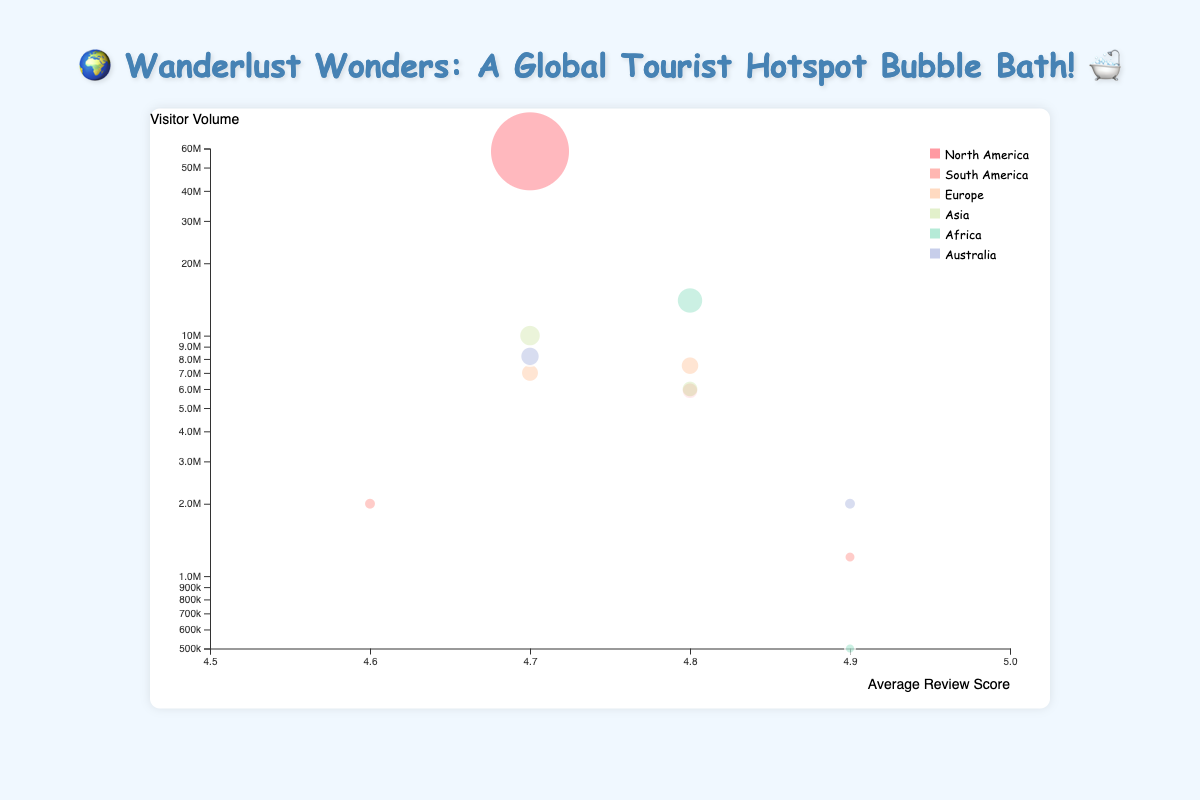How many destinations from each continent are represented in the chart? Count the number of destinations for each continent by examining the colors representing each continent.
Answer: North America: 2, South America: 2, Europe: 2, Asia: 2, Africa: 2, Australia: 2 Which destination has the highest visitor volume? Identify the bubble with the largest size at the highest position along the y-axis. The tooltip provides the visitor volume details for further clarification.
Answer: Walt Disney World What is the average review score range among all destinations? Look at the x-axis which ranges from 4.5 to 5.0. Confirm by checking the positions of the bubbles along the x-axis to see if they're within this range.
Answer: 4.6 to 4.9 Which destination in Europe has a higher average review score? Compare the average review scores of the two European destinations by checking their positions along the x-axis.
Answer: Colosseum What is the total visitor volume for the destinations in Asia? Add the visitor volumes of the Asian destinations: Great Wall of China (10,000,000) and Taj Mahal (6,000,000)
Answer: 16,000,000 Which continent has the most balanced representation of visitor volume and review score among its destinations? Evaluate the spread and size of the bubbles for each continent, ensuring that visitor volumes and review scores are not extreme within the same continent.
Answer: Australia Which destination has the highest average review score? Identify the bubble farthest to the right on the x-axis, indicating the highest average review score. Cross-verify using the tooltip details.
Answer: Machu Picchu, Victoria Falls, Great Barrier Reef How does the visitor volume of Pyramids of Giza compare to that of the Great Wall of China? Find the respective bubbles and compare their y-axis positions to see which one is higher. Cross-check the exact visitor volumes using the tooltips.
Answer: Pyramids of Giza has more visitors Which North American destination has a higher average review score? Compare the average review scores of the North American destinations by their positions along the x-axis.
Answer: Grand Canyon National Park What is the smallest visitor volume among all destinations, and which destination does it belong to? Locate the smallest bubble on the chart. Use the tooltip to confirm the exact visitor volume and the corresponding destination.
Answer: Victoria Falls, 500,000 